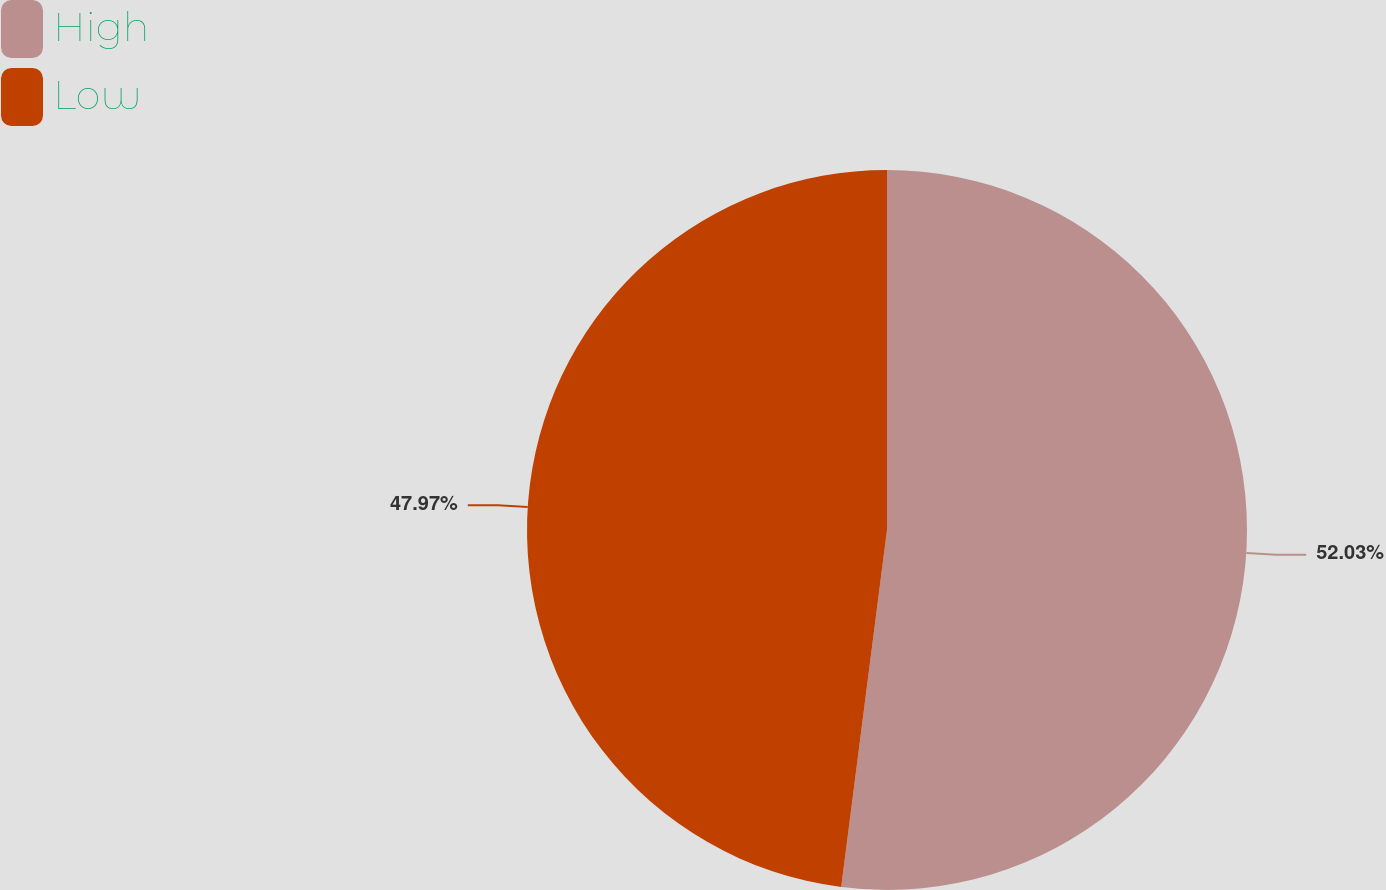Convert chart to OTSL. <chart><loc_0><loc_0><loc_500><loc_500><pie_chart><fcel>High<fcel>Low<nl><fcel>52.03%<fcel>47.97%<nl></chart> 